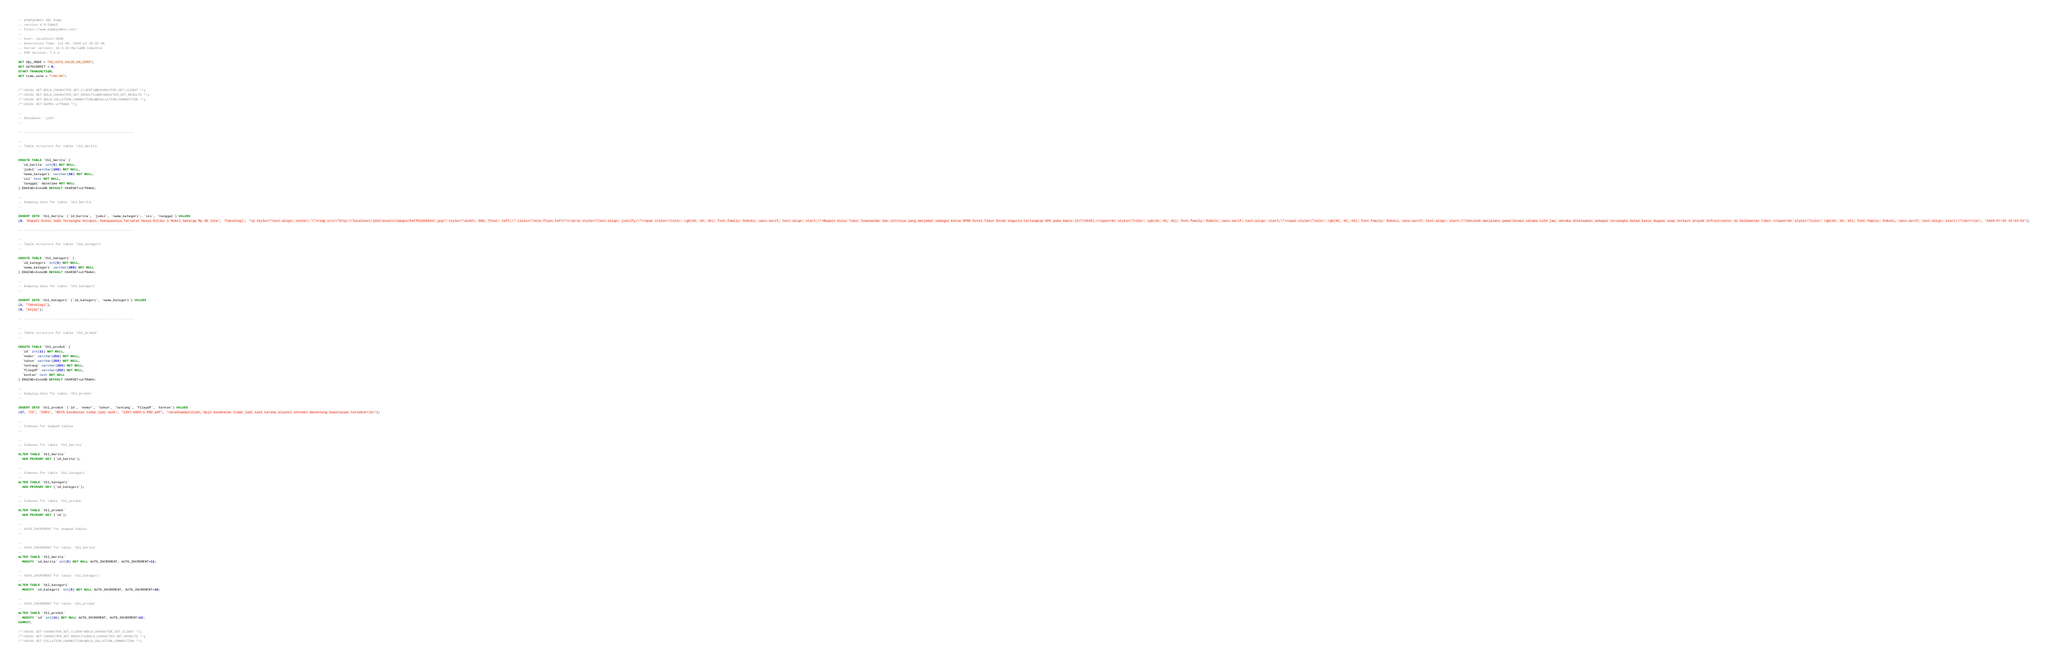Convert code to text. <code><loc_0><loc_0><loc_500><loc_500><_SQL_>-- phpMyAdmin SQL Dump
-- version 4.9.5deb2
-- https://www.phpmyadmin.net/
--
-- Host: localhost:3306
-- Generation Time: Jul 08, 2020 at 10:32 AM
-- Server version: 10.3.22-MariaDB-1ubuntu1
-- PHP Version: 7.4.3

SET SQL_MODE = "NO_AUTO_VALUE_ON_ZERO";
SET AUTOCOMMIT = 0;
START TRANSACTION;
SET time_zone = "+00:00";


/*!40101 SET @OLD_CHARACTER_SET_CLIENT=@@CHARACTER_SET_CLIENT */;
/*!40101 SET @OLD_CHARACTER_SET_RESULTS=@@CHARACTER_SET_RESULTS */;
/*!40101 SET @OLD_COLLATION_CONNECTION=@@COLLATION_CONNECTION */;
/*!40101 SET NAMES utf8mb4 */;

--
-- Database: `jdih`
--

-- --------------------------------------------------------

--
-- Table structure for table `tbl_berita`
--

CREATE TABLE `tbl_berita` (
  `id_berita` int(5) NOT NULL,
  `judul` varchar(100) NOT NULL,
  `nama_kategori` varchar(50) NOT NULL,
  `isi` text NOT NULL,
  `tanggal` datetime NOT NULL
) ENGINE=InnoDB DEFAULT CHARSET=utf8mb4;

--
-- Dumping data for table `tbl_berita`
--

INSERT INTO `tbl_berita` (`id_berita`, `judul`, `nama_kategori`, `isi`, `tanggal`) VALUES
(8, 'Bupati Kutai Jadi Tersangka Korupsi, Kekayaannya Tercatat Hanya Miliki 1 Mobil Seharga Rp 40 Juta', 'Teknologi', '<p style=\"text-align: center; \"><img src=\"http://localhost/jdih/assets/images/5eff91b5924e7.jpg\" style=\"width: 50%; float: left;\" class=\"note-float-left\"></p><p style=\"text-align: justify;\"><span style=\"color: rgb(42, 42, 42); font-family: Roboto, sans-serif; text-align: start;\">Bupati Kutai Timur Ismunandar dan istrinya yang menjabat sebagai Ketua DPRD Kutai Timur Encek Unguria tertangkap KPK pada Kamis (2/7/2020).</span><br style=\"color: rgb(42, 42, 42); font-family: Roboto, sans-serif; text-align: start;\"><span style=\"color: rgb(42, 42, 42); font-family: Roboto, sans-serif; text-align: start;\">Setelah menjalani pemeriksaan selama 1x24 jam, mereka ditetapkan sebagai tersangka dalam kasus dugaan suap terkait proyek infrastruktur di Kalimantan Timur.</span><br style=\"color: rgb(42, 42, 42); font-family: Roboto, sans-serif; text-align: start;\"><br></p>', '2020-07-01 12:43:33');

-- --------------------------------------------------------

--
-- Table structure for table `tbl_kategori`
--

CREATE TABLE `tbl_kategori` (
  `id_kategori` int(5) NOT NULL,
  `nama_kategori` varchar(300) NOT NULL
) ENGINE=InnoDB DEFAULT CHARSET=utf8mb4;

--
-- Dumping data for table `tbl_kategori`
--

INSERT INTO `tbl_kategori` (`id_kategori`, `nama_kategori`) VALUES
(1, 'Teknologi'),
(8, 'anjay');

-- --------------------------------------------------------

--
-- Table structure for table `tbl_produk`
--

CREATE TABLE `tbl_produk` (
  `id` int(11) NOT NULL,
  `nomor` varchar(255) NOT NULL,
  `tahun` varchar(255) NOT NULL,
  `tentang` varchar(255) NOT NULL,
  `filepdf` varchar(255) NOT NULL,
  `konten` text NOT NULL
) ENGINE=InnoDB DEFAULT CHARSET=utf8mb4;

--
-- Dumping data for table `tbl_produk`
--

INSERT INTO `tbl_produk` (`id`, `nomor`, `tahun`, `tentang`, `filepdf`, `konten`) VALUES
(17, '23', '2001', 'BPJS kesehatan tidak jadi naik', '1337-4065-1-PB2.pdf', '<p>alhamdulillah, bpjs kesehatan tidak jadi naik karena aliansi shinobi menentang keputuasan tersebut</p>');

--
-- Indexes for dumped tables
--

--
-- Indexes for table `tbl_berita`
--
ALTER TABLE `tbl_berita`
  ADD PRIMARY KEY (`id_berita`);

--
-- Indexes for table `tbl_kategori`
--
ALTER TABLE `tbl_kategori`
  ADD PRIMARY KEY (`id_kategori`);

--
-- Indexes for table `tbl_produk`
--
ALTER TABLE `tbl_produk`
  ADD PRIMARY KEY (`id`);

--
-- AUTO_INCREMENT for dumped tables
--

--
-- AUTO_INCREMENT for table `tbl_berita`
--
ALTER TABLE `tbl_berita`
  MODIFY `id_berita` int(5) NOT NULL AUTO_INCREMENT, AUTO_INCREMENT=11;

--
-- AUTO_INCREMENT for table `tbl_kategori`
--
ALTER TABLE `tbl_kategori`
  MODIFY `id_kategori` int(5) NOT NULL AUTO_INCREMENT, AUTO_INCREMENT=10;

--
-- AUTO_INCREMENT for table `tbl_produk`
--
ALTER TABLE `tbl_produk`
  MODIFY `id` int(11) NOT NULL AUTO_INCREMENT, AUTO_INCREMENT=22;
COMMIT;

/*!40101 SET CHARACTER_SET_CLIENT=@OLD_CHARACTER_SET_CLIENT */;
/*!40101 SET CHARACTER_SET_RESULTS=@OLD_CHARACTER_SET_RESULTS */;
/*!40101 SET COLLATION_CONNECTION=@OLD_COLLATION_CONNECTION */;
</code> 